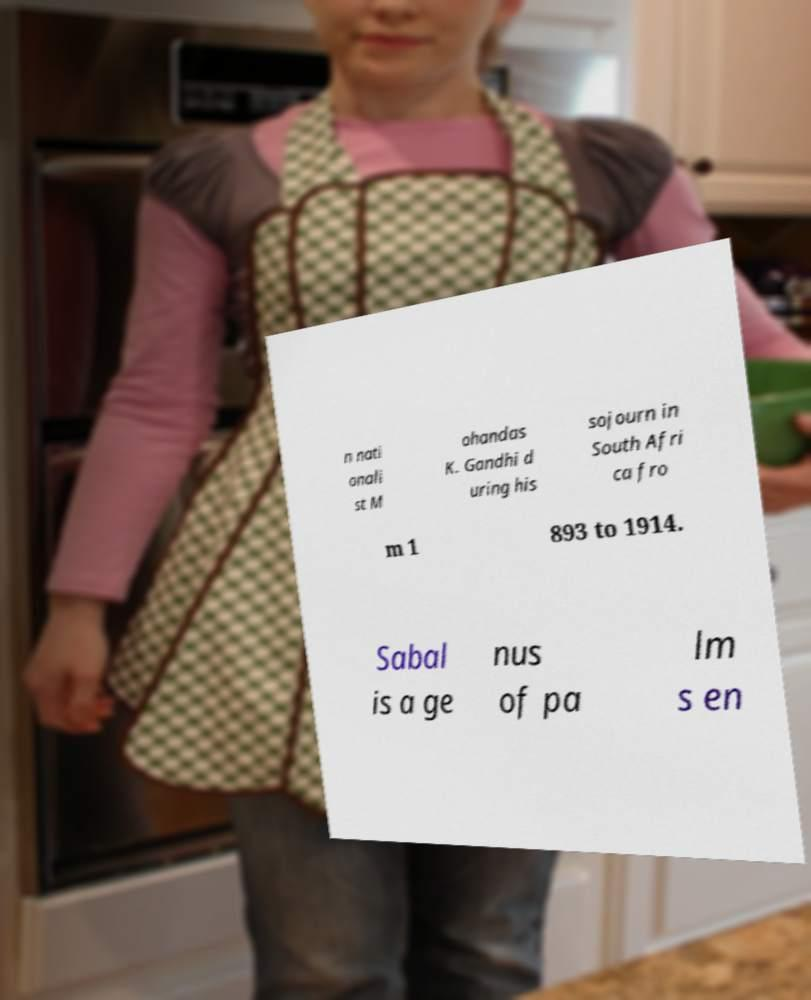What messages or text are displayed in this image? I need them in a readable, typed format. n nati onali st M ohandas K. Gandhi d uring his sojourn in South Afri ca fro m 1 893 to 1914. Sabal is a ge nus of pa lm s en 